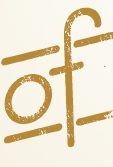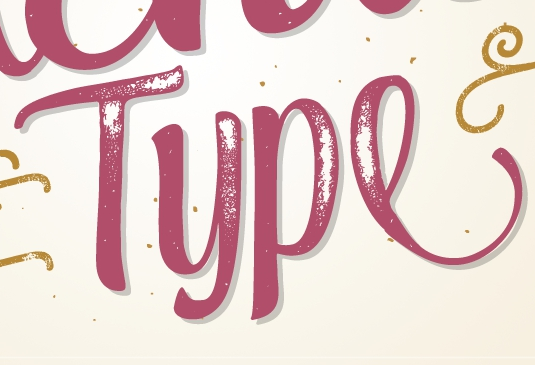What text appears in these images from left to right, separated by a semicolon? of; Type 